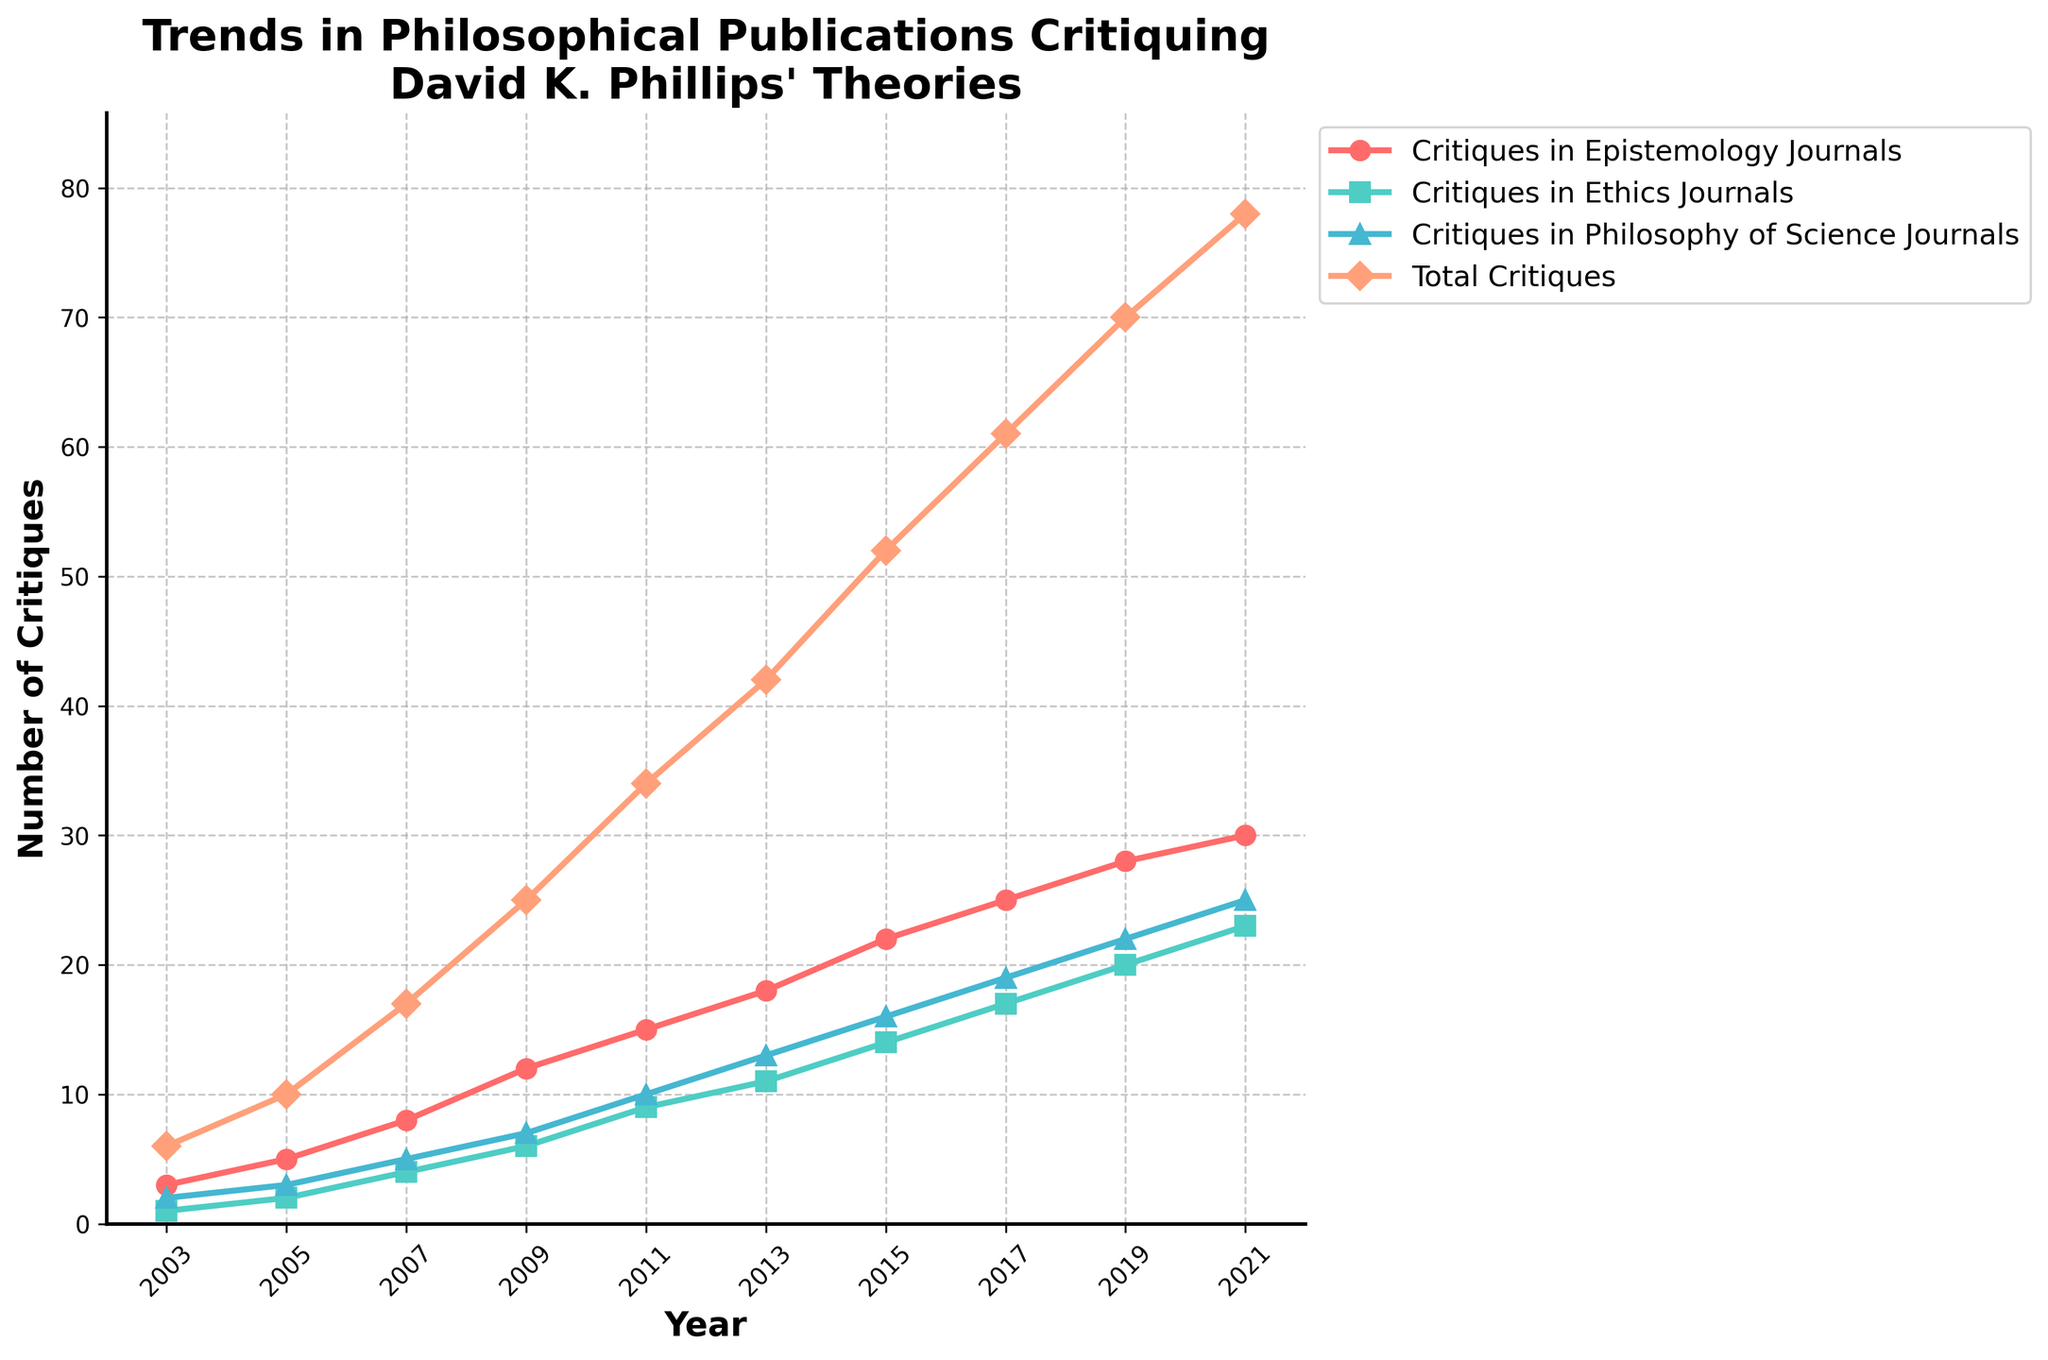How many total critiques were published in 2015? Locate the point for the year 2015 on the x-axis, then follow it up to the "Total Critiques" line. The y-axis value at this intersection is 52.
Answer: 52 Which type of journal had the highest number of critiques in 2007? Locate the year 2007 on the x-axis and examine the three lines representing critiques in different types of journals. The line representing "Critiques in Epistemology Journals" is highest at this point.
Answer: Epistemology How many more critiques were published in 2021 compared to 2003 across all journals? Look at the "Total Critiques" values for 2021 (78) and 2003 (6) on the y-axis. Subtract the value for 2003 from 2021: 78 - 6 = 72.
Answer: 72 What is the average number of critiques in Ethics Journals over the given period? Sum the y-axis values for critiques in Ethics Journals over all years (1+2+4+6+9+11+14+17+20+23 = 107). Divide by the number of years (10): 107 / 10 = 10.7.
Answer: 10.7 Which year had the biggest increase in total critiques compared to the previous year? Determine the differences in "Total Critiques" between consecutive years: 4 (2005-2003), 7 (2007-2005), 8 (2009-2007), 9 (2011-2009), 8 (2013-2011), 10 (2015-2013), 9 (2017-2015), 9 (2019-2017), 8 (2021-2019). The year with the biggest increase is 2011 with an increase of 9 critiques.
Answer: 2011 What can be inferred from the visual difference in the height of the "Critiques in Philosophy of Science Journals" line between 2009 and 2013? The line representing "Critiques in Philosophy of Science Journals" increased from a y-axis value of 7 in 2009 to 13 in 2013, showing a rise by 6 critiques over these years.
Answer: Rise by 6 critiques In which year did critiques in Ethics Journals first exceed those in Philosophy of Science Journals? Compare the y-axis values for "Critiques in Ethics Journals" and "Critiques in Philosophy of Science Journals" for each year until Ethics exceeds Philosophy of Science. In 2007, Ethics Journals (4) first exceed Philosophy of Science Journals (3).
Answer: 2007 What is the cumulative number of critiques published in Epistemology and Ethics Journals in 2019? Add the critiques from Epistemology Journals (28) and Ethics Journals (20) in 2019: 28 + 20 = 48.
Answer: 48 By how much did the total number of critiques increase from 2017 to 2019? Subtract the "Total Critiques" for 2017 (61) from the value in 2019 (70): 70 - 61 = 9.
Answer: 9 Which journal type shows the steadiest increase in critiques over the years? Visually compare the lines for each journal type to see which line is the smoothest without any sudden jumps. The line for "Critiques in Epistemology Journals" shows the steadiest increase.
Answer: Epistemology Journals 